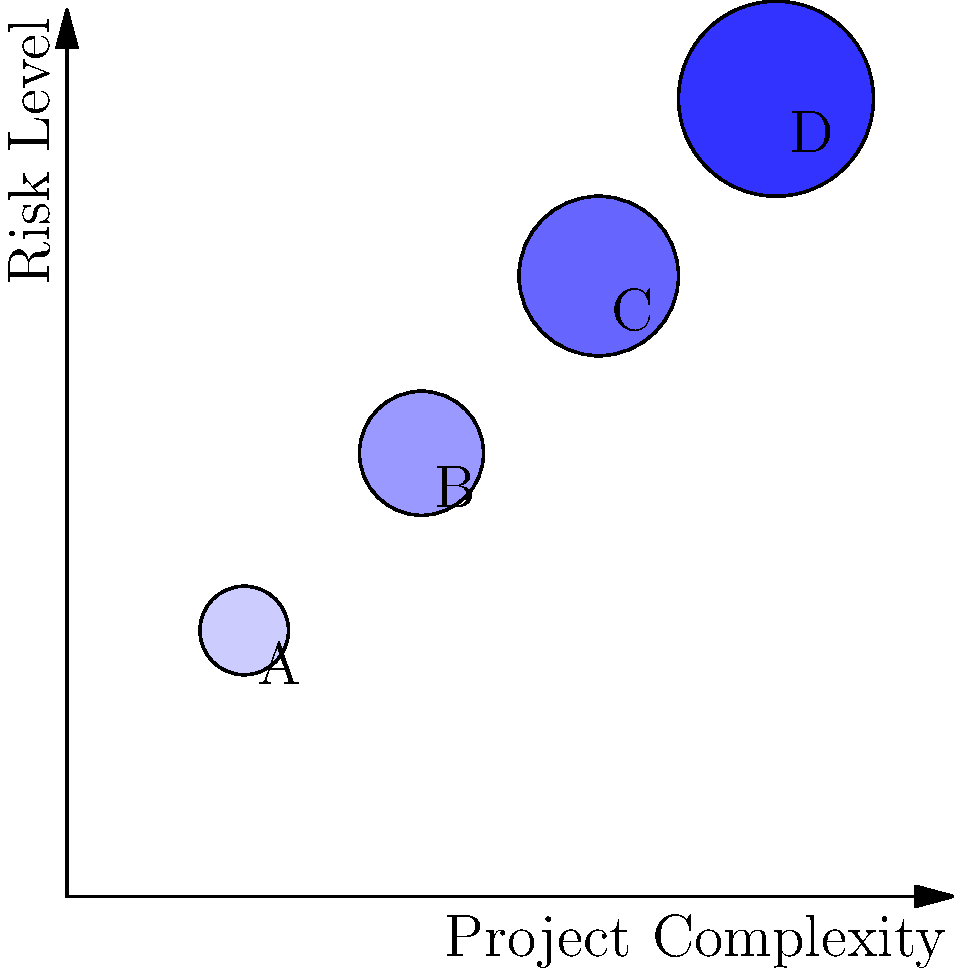Based on the bubble chart illustrating the relationship between project complexity and risk, which project (A, B, C, or D) demonstrates the highest level of both complexity and risk? How does this observation align with common project management theories about the correlation between complexity and risk? To answer this question, we need to analyze the bubble chart and understand the relationship between project complexity and risk:

1. Interpret the axes:
   - X-axis represents Project Complexity (increasing from left to right)
   - Y-axis represents Risk Level (increasing from bottom to top)

2. Analyze the position of each project bubble:
   - Project A: (2,3) - Low complexity, low risk
   - Project B: (4,5) - Medium complexity, medium risk
   - Project C: (6,7) - High complexity, high risk
   - Project D: (8,9) - Highest complexity, highest risk

3. Identify the project with the highest complexity and risk:
   - Project D is positioned at the top-right corner, indicating the highest levels of both complexity and risk.

4. Relate to project management theories:
   - This observation aligns with the common project management theory that increased project complexity often correlates with higher risk levels.
   - Complex projects typically involve more variables, stakeholders, and interdependencies, which can lead to increased uncertainties and potential for issues.

5. Consider the bubble sizes:
   - The bubble sizes increase from A to D, which could represent additional factors such as project budget or team size.
   - This further supports the idea that larger, more complex projects tend to carry higher risks.
Answer: Project D; aligns with theory that higher complexity correlates with increased risk. 